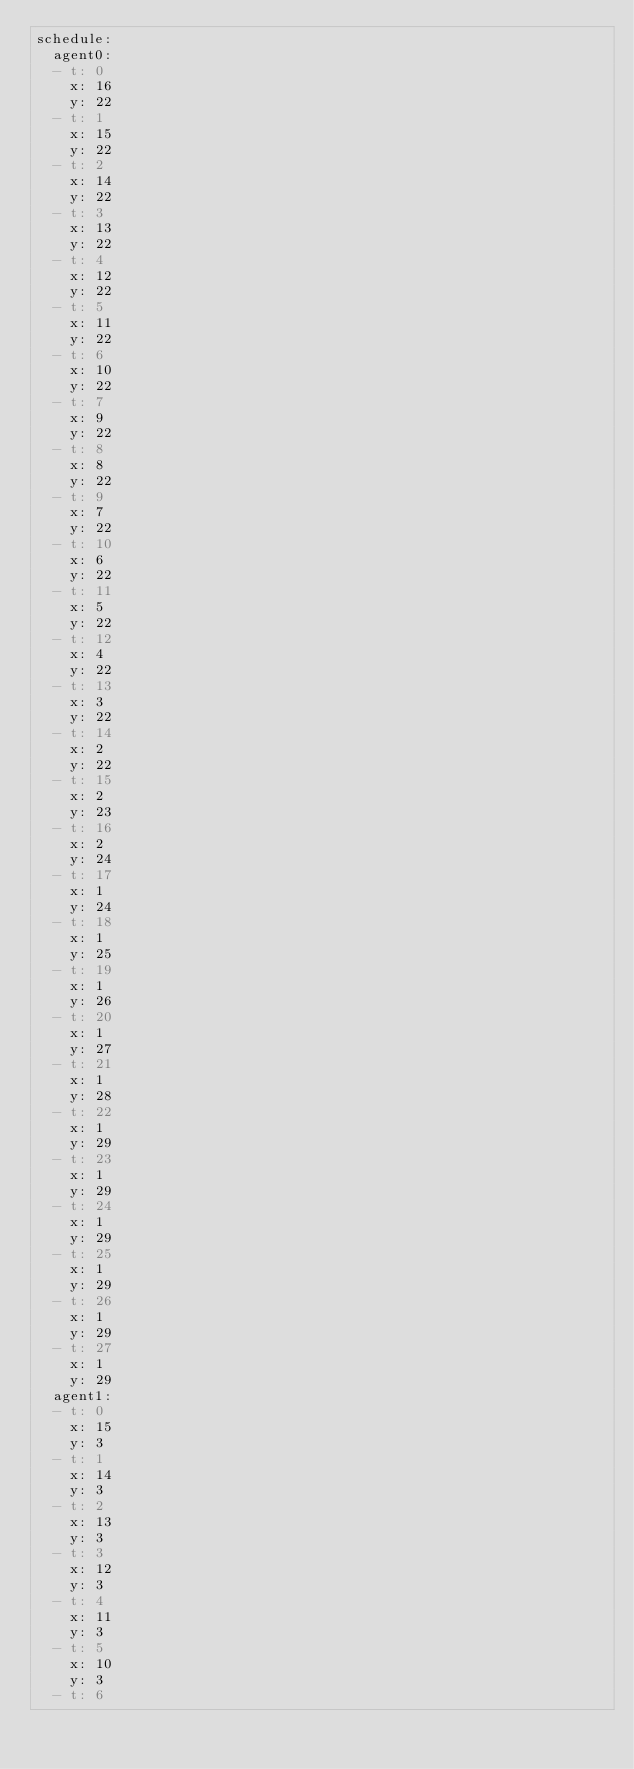Convert code to text. <code><loc_0><loc_0><loc_500><loc_500><_YAML_>schedule:
  agent0:
  - t: 0
    x: 16
    y: 22
  - t: 1
    x: 15
    y: 22
  - t: 2
    x: 14
    y: 22
  - t: 3
    x: 13
    y: 22
  - t: 4
    x: 12
    y: 22
  - t: 5
    x: 11
    y: 22
  - t: 6
    x: 10
    y: 22
  - t: 7
    x: 9
    y: 22
  - t: 8
    x: 8
    y: 22
  - t: 9
    x: 7
    y: 22
  - t: 10
    x: 6
    y: 22
  - t: 11
    x: 5
    y: 22
  - t: 12
    x: 4
    y: 22
  - t: 13
    x: 3
    y: 22
  - t: 14
    x: 2
    y: 22
  - t: 15
    x: 2
    y: 23
  - t: 16
    x: 2
    y: 24
  - t: 17
    x: 1
    y: 24
  - t: 18
    x: 1
    y: 25
  - t: 19
    x: 1
    y: 26
  - t: 20
    x: 1
    y: 27
  - t: 21
    x: 1
    y: 28
  - t: 22
    x: 1
    y: 29
  - t: 23
    x: 1
    y: 29
  - t: 24
    x: 1
    y: 29
  - t: 25
    x: 1
    y: 29
  - t: 26
    x: 1
    y: 29
  - t: 27
    x: 1
    y: 29
  agent1:
  - t: 0
    x: 15
    y: 3
  - t: 1
    x: 14
    y: 3
  - t: 2
    x: 13
    y: 3
  - t: 3
    x: 12
    y: 3
  - t: 4
    x: 11
    y: 3
  - t: 5
    x: 10
    y: 3
  - t: 6</code> 